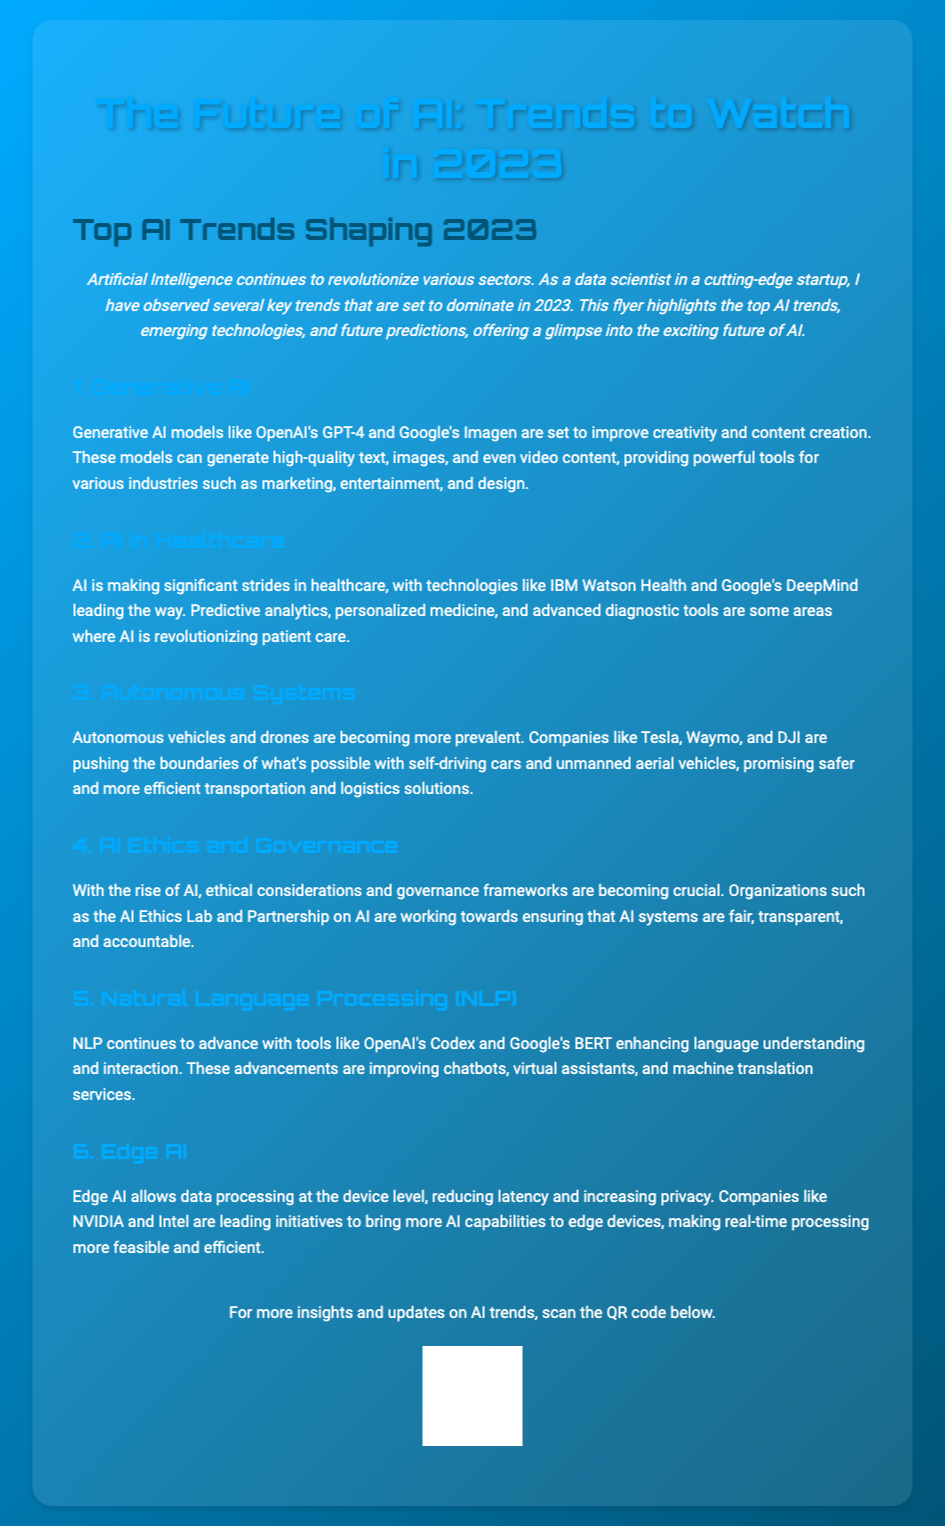What is the title of the flyer? The title of the flyer is prominently displayed at the top of the document, highlighting its focus on AI trends.
Answer: The Future of AI: Trends to Watch in 2023 How many trends are discussed in the flyer? The flyer outlines the key trends in artificial intelligence and groups them into sections.
Answer: Six Which AI model is mentioned as a generative AI example? The flyer cites specific generative AI models to illustrate current technology trends in AI content creation.
Answer: GPT-4 What industry is highlighted for AI advancements in healthcare? The document emphasizes the impact of AI on a specific industry, showcasing examples and applications in that field.
Answer: Healthcare Which company is associated with autonomous vehicles? The flyer refers to companies that are pioneering advancements in autonomous systems, specifically in transportation.
Answer: Tesla What is the focus of AI Ethics and Governance mentioned in the flyer? The content discusses the importance of ethical considerations surrounding AI as it continues to evolve and impact various sectors.
Answer: Fairness and accountability What does Edge AI enable? The flyer explains the advantages of Edge AI as it pertains to data processing and efficiency related to device-level operations.
Answer: Real-time processing Which organization's work is referenced in relation to AI ethics? The document mentions specific organizations focusing on the ethical implications and regulations associated with AI development.
Answer: AI Ethics Lab 